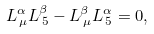<formula> <loc_0><loc_0><loc_500><loc_500>L ^ { \alpha } _ { \, \mu } L ^ { \beta } _ { \, 5 } - L ^ { \beta } _ { \, \mu } L ^ { \alpha } _ { \, 5 } = 0 ,</formula> 